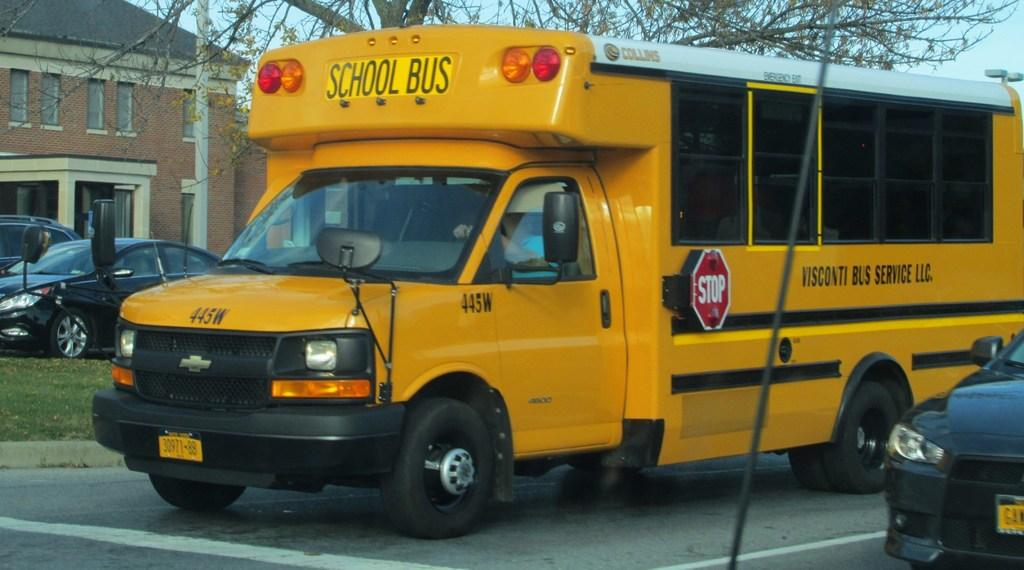<image>
Write a terse but informative summary of the picture. Yellow school bus with a black car parked beside it 